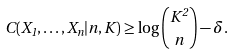<formula> <loc_0><loc_0><loc_500><loc_500>C ( X _ { 1 } , \dots , X _ { n } | n , K ) \geq \log { K ^ { 2 } \choose n } - \delta .</formula> 